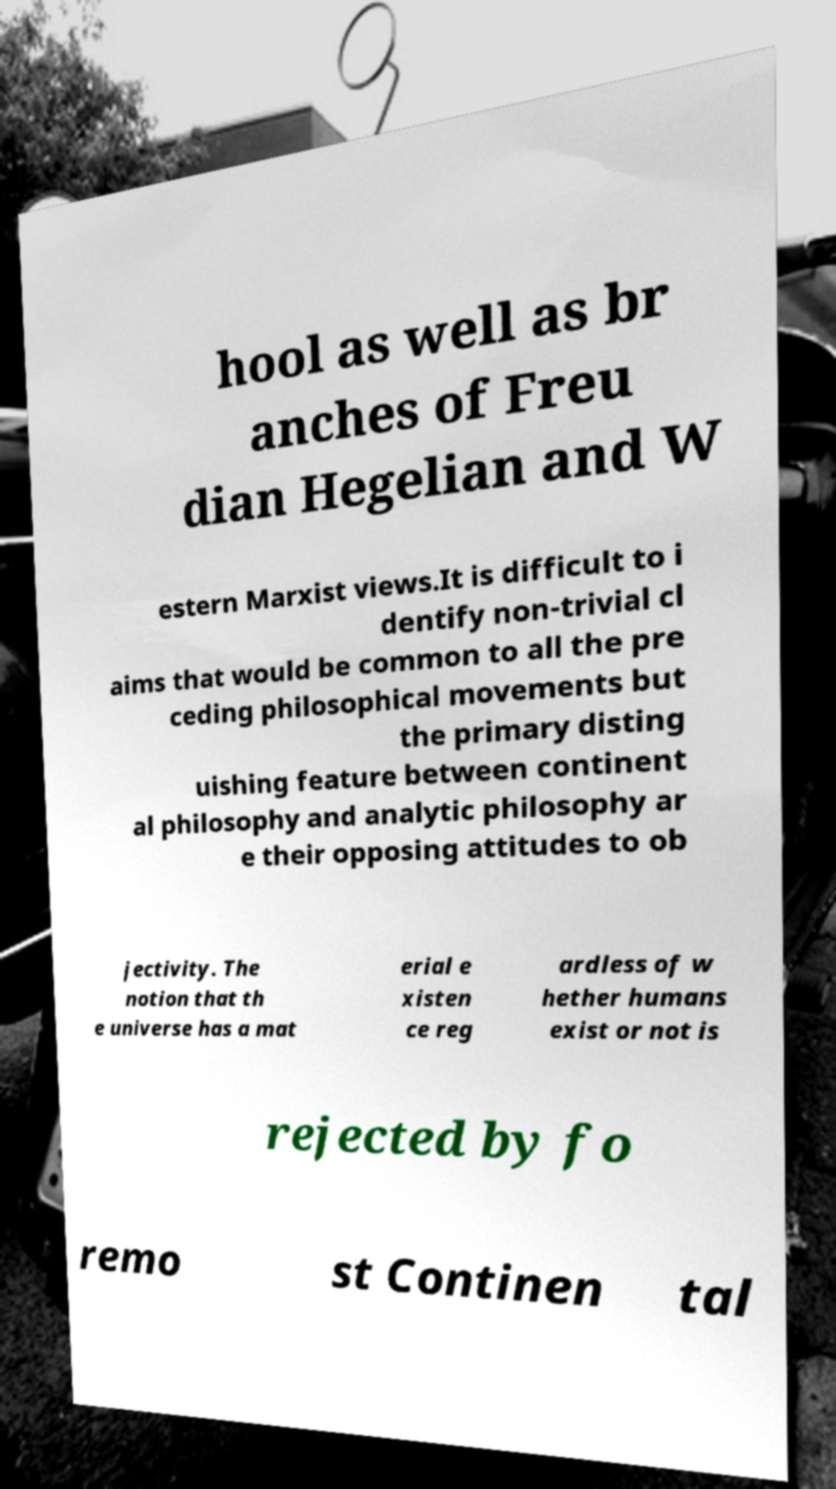Could you assist in decoding the text presented in this image and type it out clearly? hool as well as br anches of Freu dian Hegelian and W estern Marxist views.It is difficult to i dentify non-trivial cl aims that would be common to all the pre ceding philosophical movements but the primary disting uishing feature between continent al philosophy and analytic philosophy ar e their opposing attitudes to ob jectivity. The notion that th e universe has a mat erial e xisten ce reg ardless of w hether humans exist or not is rejected by fo remo st Continen tal 